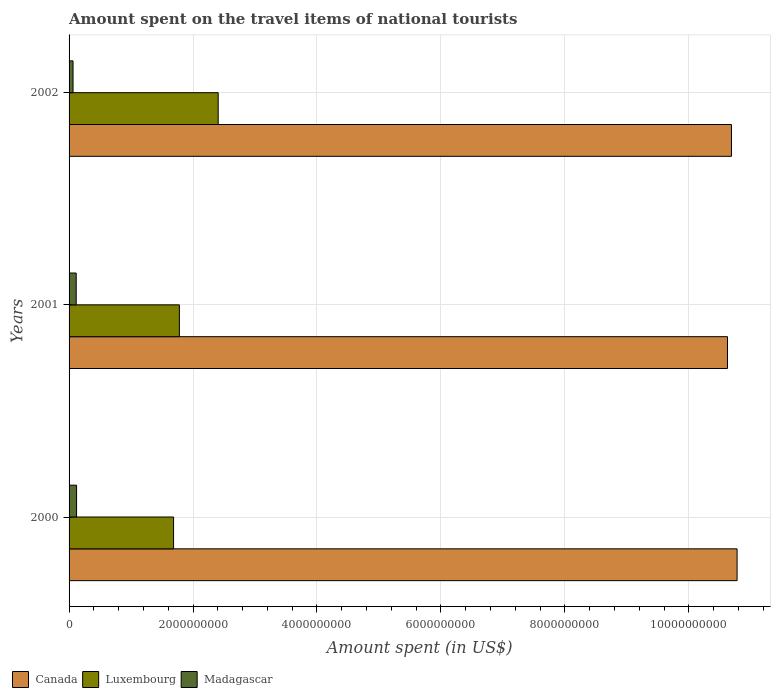Are the number of bars on each tick of the Y-axis equal?
Your response must be concise. Yes. How many bars are there on the 3rd tick from the bottom?
Your answer should be compact. 3. What is the label of the 2nd group of bars from the top?
Ensure brevity in your answer.  2001. In how many cases, is the number of bars for a given year not equal to the number of legend labels?
Make the answer very short. 0. What is the amount spent on the travel items of national tourists in Canada in 2000?
Your response must be concise. 1.08e+1. Across all years, what is the maximum amount spent on the travel items of national tourists in Madagascar?
Your answer should be compact. 1.21e+08. Across all years, what is the minimum amount spent on the travel items of national tourists in Luxembourg?
Provide a succinct answer. 1.69e+09. In which year was the amount spent on the travel items of national tourists in Canada minimum?
Keep it short and to the point. 2001. What is the total amount spent on the travel items of national tourists in Madagascar in the graph?
Provide a short and direct response. 3.00e+08. What is the difference between the amount spent on the travel items of national tourists in Madagascar in 2000 and that in 2002?
Make the answer very short. 5.70e+07. What is the difference between the amount spent on the travel items of national tourists in Luxembourg in 2001 and the amount spent on the travel items of national tourists in Madagascar in 2002?
Provide a succinct answer. 1.72e+09. What is the average amount spent on the travel items of national tourists in Canada per year?
Ensure brevity in your answer.  1.07e+1. In the year 2002, what is the difference between the amount spent on the travel items of national tourists in Madagascar and amount spent on the travel items of national tourists in Canada?
Provide a short and direct response. -1.06e+1. What is the ratio of the amount spent on the travel items of national tourists in Luxembourg in 2000 to that in 2002?
Your answer should be compact. 0.7. Is the amount spent on the travel items of national tourists in Canada in 2000 less than that in 2002?
Offer a very short reply. No. What is the difference between the highest and the second highest amount spent on the travel items of national tourists in Canada?
Keep it short and to the point. 9.10e+07. What is the difference between the highest and the lowest amount spent on the travel items of national tourists in Canada?
Provide a short and direct response. 1.55e+08. In how many years, is the amount spent on the travel items of national tourists in Canada greater than the average amount spent on the travel items of national tourists in Canada taken over all years?
Your response must be concise. 1. What does the 3rd bar from the top in 2001 represents?
Provide a succinct answer. Canada. What does the 1st bar from the bottom in 2000 represents?
Your answer should be compact. Canada. Are all the bars in the graph horizontal?
Provide a short and direct response. Yes. What is the difference between two consecutive major ticks on the X-axis?
Make the answer very short. 2.00e+09. Are the values on the major ticks of X-axis written in scientific E-notation?
Keep it short and to the point. No. Does the graph contain grids?
Give a very brief answer. Yes. How many legend labels are there?
Your answer should be compact. 3. How are the legend labels stacked?
Offer a very short reply. Horizontal. What is the title of the graph?
Your answer should be compact. Amount spent on the travel items of national tourists. What is the label or title of the X-axis?
Your answer should be very brief. Amount spent (in US$). What is the label or title of the Y-axis?
Offer a terse response. Years. What is the Amount spent (in US$) in Canada in 2000?
Give a very brief answer. 1.08e+1. What is the Amount spent (in US$) of Luxembourg in 2000?
Provide a succinct answer. 1.69e+09. What is the Amount spent (in US$) of Madagascar in 2000?
Your response must be concise. 1.21e+08. What is the Amount spent (in US$) in Canada in 2001?
Provide a succinct answer. 1.06e+1. What is the Amount spent (in US$) of Luxembourg in 2001?
Offer a very short reply. 1.78e+09. What is the Amount spent (in US$) in Madagascar in 2001?
Ensure brevity in your answer.  1.15e+08. What is the Amount spent (in US$) of Canada in 2002?
Your answer should be compact. 1.07e+1. What is the Amount spent (in US$) in Luxembourg in 2002?
Your answer should be very brief. 2.41e+09. What is the Amount spent (in US$) of Madagascar in 2002?
Provide a succinct answer. 6.40e+07. Across all years, what is the maximum Amount spent (in US$) of Canada?
Offer a terse response. 1.08e+1. Across all years, what is the maximum Amount spent (in US$) in Luxembourg?
Your answer should be very brief. 2.41e+09. Across all years, what is the maximum Amount spent (in US$) of Madagascar?
Your answer should be very brief. 1.21e+08. Across all years, what is the minimum Amount spent (in US$) in Canada?
Your response must be concise. 1.06e+1. Across all years, what is the minimum Amount spent (in US$) in Luxembourg?
Provide a succinct answer. 1.69e+09. Across all years, what is the minimum Amount spent (in US$) of Madagascar?
Provide a short and direct response. 6.40e+07. What is the total Amount spent (in US$) in Canada in the graph?
Offer a very short reply. 3.21e+1. What is the total Amount spent (in US$) in Luxembourg in the graph?
Offer a terse response. 5.87e+09. What is the total Amount spent (in US$) of Madagascar in the graph?
Offer a terse response. 3.00e+08. What is the difference between the Amount spent (in US$) of Canada in 2000 and that in 2001?
Your answer should be very brief. 1.55e+08. What is the difference between the Amount spent (in US$) of Luxembourg in 2000 and that in 2001?
Offer a terse response. -9.40e+07. What is the difference between the Amount spent (in US$) of Madagascar in 2000 and that in 2001?
Ensure brevity in your answer.  6.00e+06. What is the difference between the Amount spent (in US$) of Canada in 2000 and that in 2002?
Make the answer very short. 9.10e+07. What is the difference between the Amount spent (in US$) of Luxembourg in 2000 and that in 2002?
Keep it short and to the point. -7.20e+08. What is the difference between the Amount spent (in US$) in Madagascar in 2000 and that in 2002?
Offer a terse response. 5.70e+07. What is the difference between the Amount spent (in US$) in Canada in 2001 and that in 2002?
Provide a short and direct response. -6.40e+07. What is the difference between the Amount spent (in US$) in Luxembourg in 2001 and that in 2002?
Offer a very short reply. -6.26e+08. What is the difference between the Amount spent (in US$) in Madagascar in 2001 and that in 2002?
Keep it short and to the point. 5.10e+07. What is the difference between the Amount spent (in US$) of Canada in 2000 and the Amount spent (in US$) of Luxembourg in 2001?
Your response must be concise. 9.00e+09. What is the difference between the Amount spent (in US$) of Canada in 2000 and the Amount spent (in US$) of Madagascar in 2001?
Your answer should be very brief. 1.07e+1. What is the difference between the Amount spent (in US$) of Luxembourg in 2000 and the Amount spent (in US$) of Madagascar in 2001?
Your answer should be compact. 1.57e+09. What is the difference between the Amount spent (in US$) of Canada in 2000 and the Amount spent (in US$) of Luxembourg in 2002?
Your answer should be compact. 8.37e+09. What is the difference between the Amount spent (in US$) in Canada in 2000 and the Amount spent (in US$) in Madagascar in 2002?
Provide a short and direct response. 1.07e+1. What is the difference between the Amount spent (in US$) of Luxembourg in 2000 and the Amount spent (in US$) of Madagascar in 2002?
Offer a very short reply. 1.62e+09. What is the difference between the Amount spent (in US$) of Canada in 2001 and the Amount spent (in US$) of Luxembourg in 2002?
Provide a short and direct response. 8.22e+09. What is the difference between the Amount spent (in US$) of Canada in 2001 and the Amount spent (in US$) of Madagascar in 2002?
Your response must be concise. 1.06e+1. What is the difference between the Amount spent (in US$) in Luxembourg in 2001 and the Amount spent (in US$) in Madagascar in 2002?
Offer a very short reply. 1.72e+09. What is the average Amount spent (in US$) in Canada per year?
Keep it short and to the point. 1.07e+1. What is the average Amount spent (in US$) in Luxembourg per year?
Provide a short and direct response. 1.96e+09. In the year 2000, what is the difference between the Amount spent (in US$) of Canada and Amount spent (in US$) of Luxembourg?
Make the answer very short. 9.09e+09. In the year 2000, what is the difference between the Amount spent (in US$) in Canada and Amount spent (in US$) in Madagascar?
Give a very brief answer. 1.07e+1. In the year 2000, what is the difference between the Amount spent (in US$) in Luxembourg and Amount spent (in US$) in Madagascar?
Your answer should be compact. 1.56e+09. In the year 2001, what is the difference between the Amount spent (in US$) in Canada and Amount spent (in US$) in Luxembourg?
Your answer should be compact. 8.84e+09. In the year 2001, what is the difference between the Amount spent (in US$) in Canada and Amount spent (in US$) in Madagascar?
Provide a short and direct response. 1.05e+1. In the year 2001, what is the difference between the Amount spent (in US$) in Luxembourg and Amount spent (in US$) in Madagascar?
Your response must be concise. 1.66e+09. In the year 2002, what is the difference between the Amount spent (in US$) of Canada and Amount spent (in US$) of Luxembourg?
Give a very brief answer. 8.28e+09. In the year 2002, what is the difference between the Amount spent (in US$) in Canada and Amount spent (in US$) in Madagascar?
Provide a succinct answer. 1.06e+1. In the year 2002, what is the difference between the Amount spent (in US$) in Luxembourg and Amount spent (in US$) in Madagascar?
Provide a succinct answer. 2.34e+09. What is the ratio of the Amount spent (in US$) of Canada in 2000 to that in 2001?
Offer a terse response. 1.01. What is the ratio of the Amount spent (in US$) in Luxembourg in 2000 to that in 2001?
Keep it short and to the point. 0.95. What is the ratio of the Amount spent (in US$) of Madagascar in 2000 to that in 2001?
Your response must be concise. 1.05. What is the ratio of the Amount spent (in US$) in Canada in 2000 to that in 2002?
Ensure brevity in your answer.  1.01. What is the ratio of the Amount spent (in US$) in Luxembourg in 2000 to that in 2002?
Your answer should be very brief. 0.7. What is the ratio of the Amount spent (in US$) in Madagascar in 2000 to that in 2002?
Provide a succinct answer. 1.89. What is the ratio of the Amount spent (in US$) in Canada in 2001 to that in 2002?
Keep it short and to the point. 0.99. What is the ratio of the Amount spent (in US$) of Luxembourg in 2001 to that in 2002?
Make the answer very short. 0.74. What is the ratio of the Amount spent (in US$) in Madagascar in 2001 to that in 2002?
Give a very brief answer. 1.8. What is the difference between the highest and the second highest Amount spent (in US$) in Canada?
Your answer should be very brief. 9.10e+07. What is the difference between the highest and the second highest Amount spent (in US$) in Luxembourg?
Ensure brevity in your answer.  6.26e+08. What is the difference between the highest and the second highest Amount spent (in US$) of Madagascar?
Your answer should be compact. 6.00e+06. What is the difference between the highest and the lowest Amount spent (in US$) in Canada?
Your response must be concise. 1.55e+08. What is the difference between the highest and the lowest Amount spent (in US$) in Luxembourg?
Offer a terse response. 7.20e+08. What is the difference between the highest and the lowest Amount spent (in US$) of Madagascar?
Make the answer very short. 5.70e+07. 